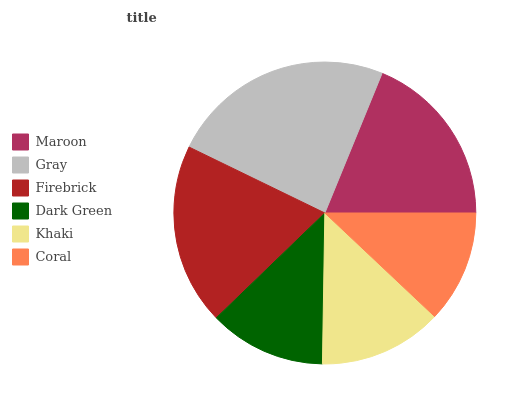Is Coral the minimum?
Answer yes or no. Yes. Is Gray the maximum?
Answer yes or no. Yes. Is Firebrick the minimum?
Answer yes or no. No. Is Firebrick the maximum?
Answer yes or no. No. Is Gray greater than Firebrick?
Answer yes or no. Yes. Is Firebrick less than Gray?
Answer yes or no. Yes. Is Firebrick greater than Gray?
Answer yes or no. No. Is Gray less than Firebrick?
Answer yes or no. No. Is Maroon the high median?
Answer yes or no. Yes. Is Khaki the low median?
Answer yes or no. Yes. Is Gray the high median?
Answer yes or no. No. Is Maroon the low median?
Answer yes or no. No. 